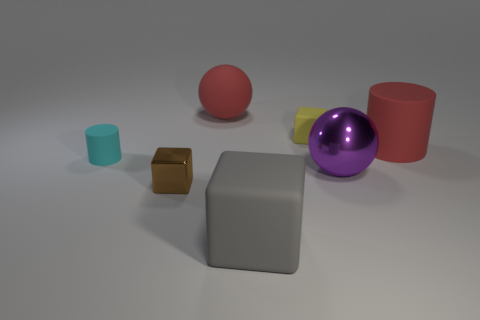What shape is the small object that is left of the rubber ball and on the right side of the cyan matte thing?
Offer a terse response. Cube. The cube that is the same size as the purple ball is what color?
Provide a short and direct response. Gray. Are there any small things that have the same color as the large shiny sphere?
Your response must be concise. No. There is a yellow cube that is left of the purple ball; is its size the same as the matte thing on the left side of the brown metal object?
Keep it short and to the point. Yes. The large thing that is both on the left side of the big red cylinder and to the right of the yellow matte cube is made of what material?
Keep it short and to the point. Metal. There is a cylinder that is the same color as the matte ball; what size is it?
Make the answer very short. Large. What number of other things are the same size as the yellow block?
Your response must be concise. 2. There is a large object left of the large gray cube; what is its material?
Provide a succinct answer. Rubber. Does the tiny brown thing have the same shape as the large gray thing?
Make the answer very short. Yes. How many other objects are the same shape as the cyan object?
Keep it short and to the point. 1. 